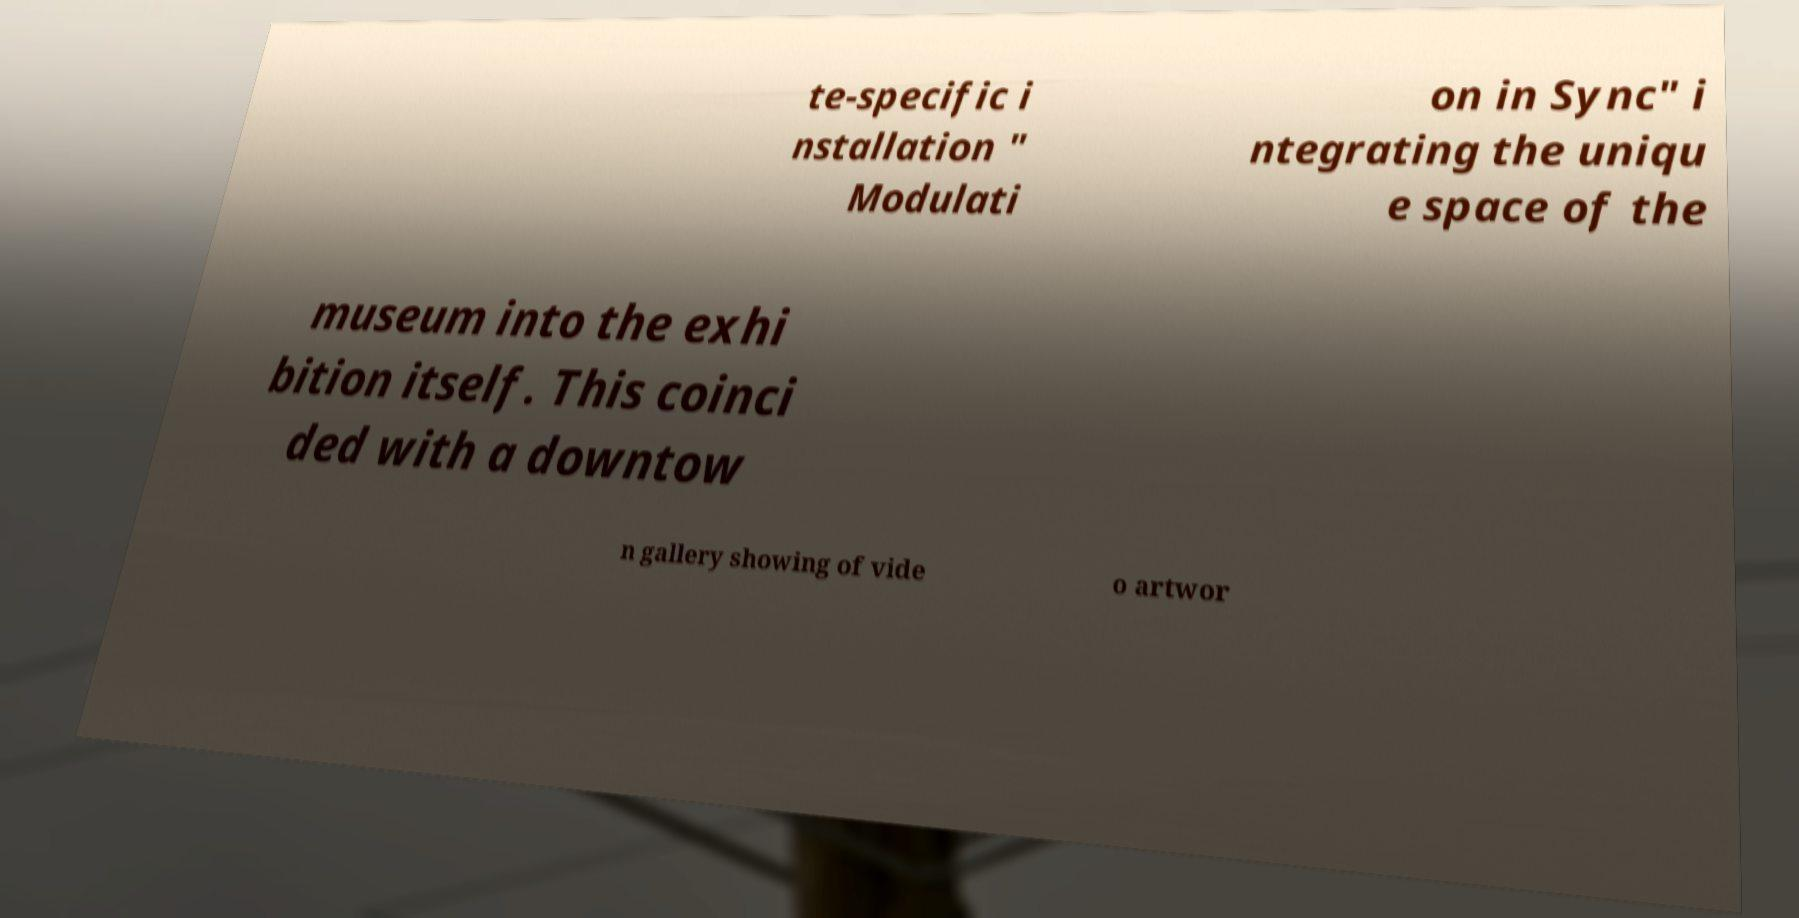Could you extract and type out the text from this image? te-specific i nstallation " Modulati on in Sync" i ntegrating the uniqu e space of the museum into the exhi bition itself. This coinci ded with a downtow n gallery showing of vide o artwor 